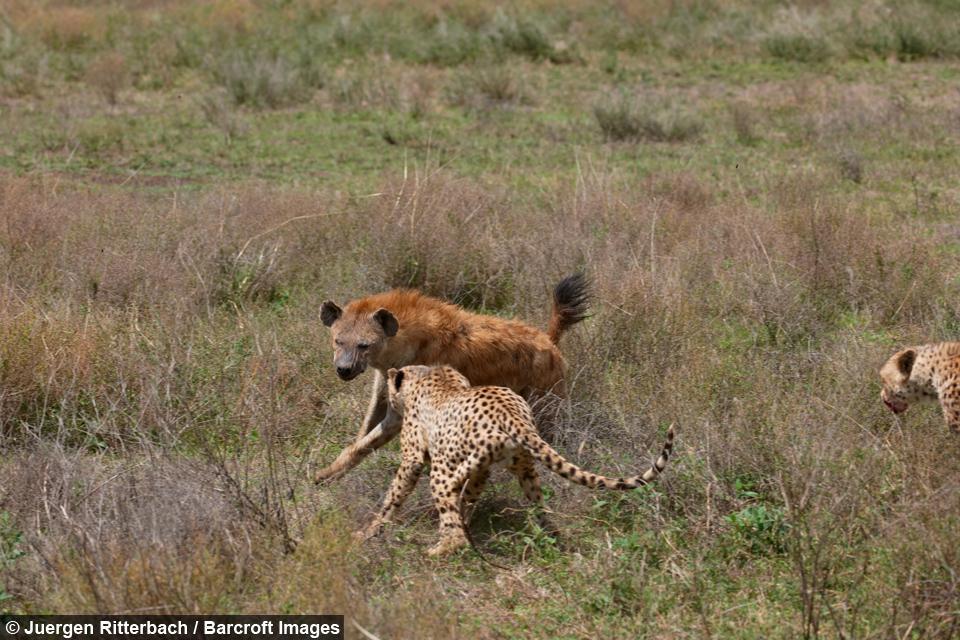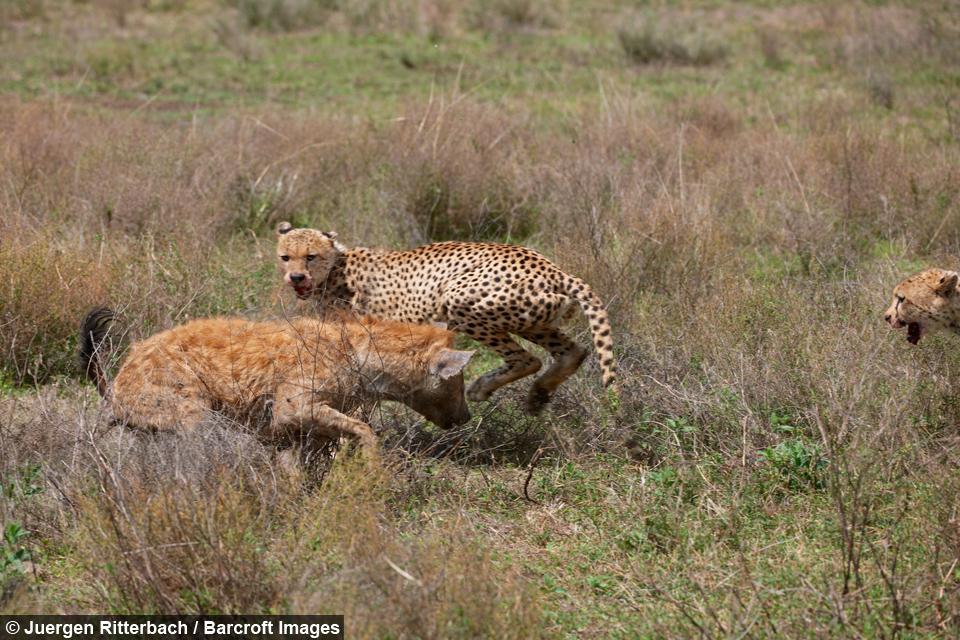The first image is the image on the left, the second image is the image on the right. Evaluate the accuracy of this statement regarding the images: "There are no more than four cheetahs.". Is it true? Answer yes or no. Yes. The first image is the image on the left, the second image is the image on the right. Given the left and right images, does the statement "Left image shows spotted wild cats attacking an upright hooved animal." hold true? Answer yes or no. No. 